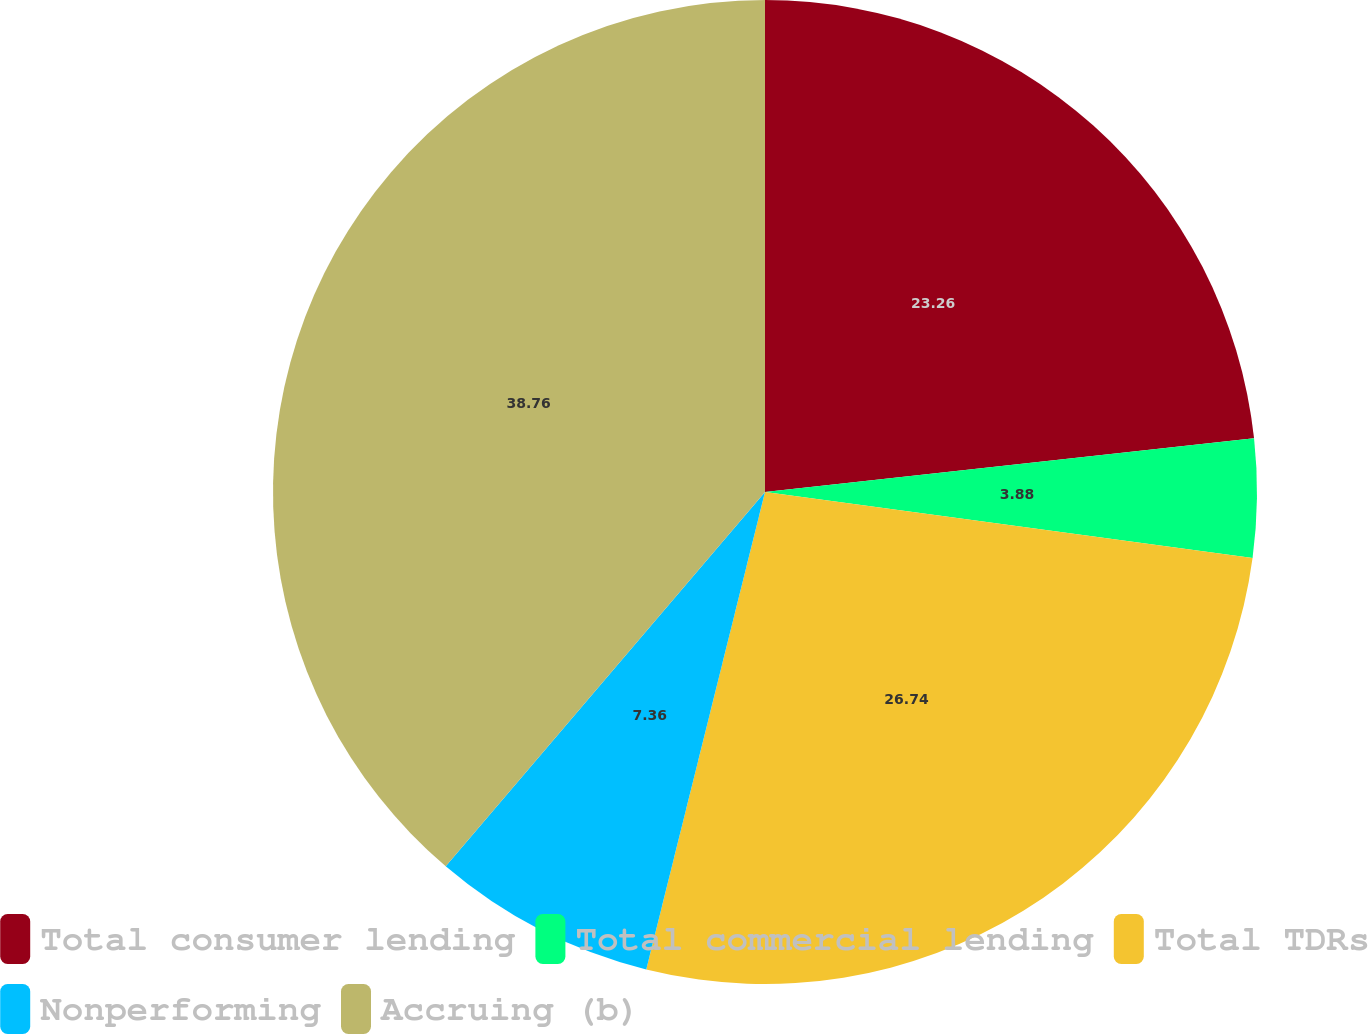Convert chart. <chart><loc_0><loc_0><loc_500><loc_500><pie_chart><fcel>Total consumer lending<fcel>Total commercial lending<fcel>Total TDRs<fcel>Nonperforming<fcel>Accruing (b)<nl><fcel>23.26%<fcel>3.88%<fcel>26.74%<fcel>7.36%<fcel>38.76%<nl></chart> 